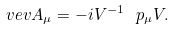<formula> <loc_0><loc_0><loc_500><loc_500>\ v e v { A _ { \mu } } = - i V ^ { - 1 } \ p _ { \mu } V .</formula> 